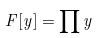<formula> <loc_0><loc_0><loc_500><loc_500>F [ y ] = \prod y</formula> 